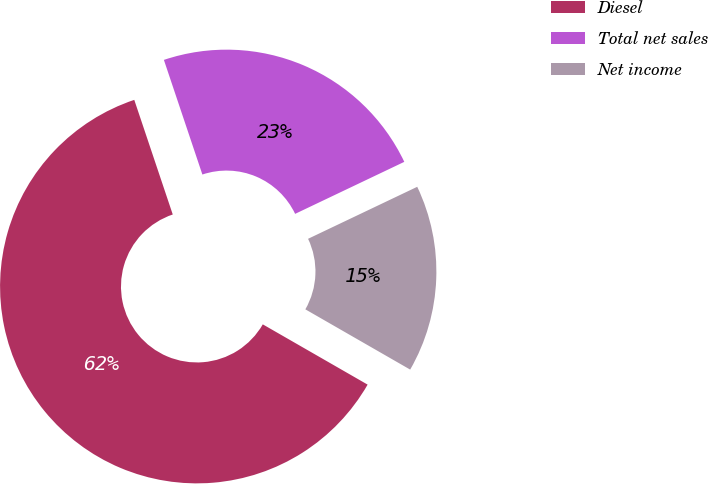<chart> <loc_0><loc_0><loc_500><loc_500><pie_chart><fcel>Diesel<fcel>Total net sales<fcel>Net income<nl><fcel>61.54%<fcel>23.08%<fcel>15.38%<nl></chart> 